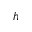<formula> <loc_0><loc_0><loc_500><loc_500>h</formula> 